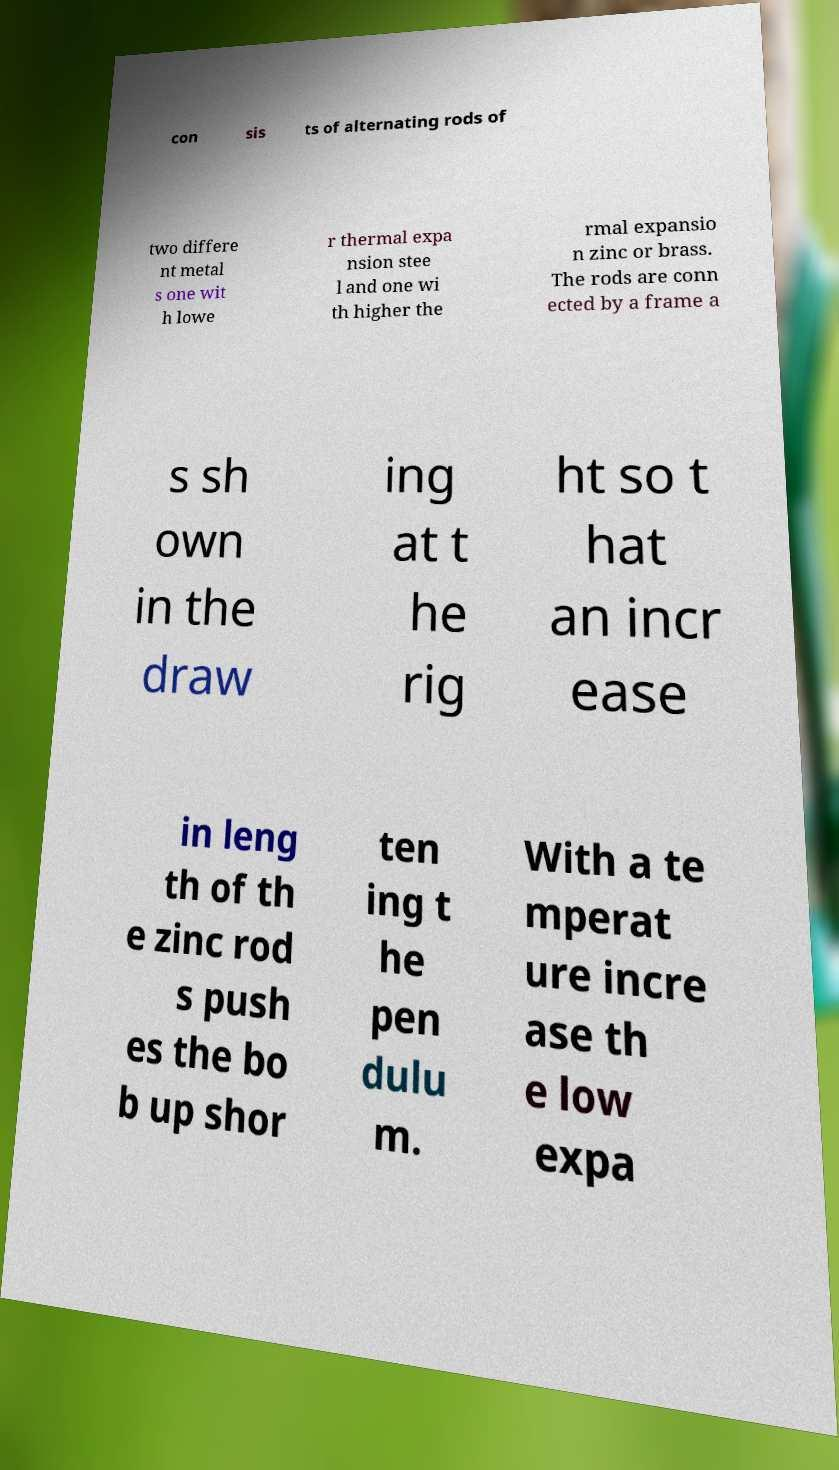For documentation purposes, I need the text within this image transcribed. Could you provide that? con sis ts of alternating rods of two differe nt metal s one wit h lowe r thermal expa nsion stee l and one wi th higher the rmal expansio n zinc or brass. The rods are conn ected by a frame a s sh own in the draw ing at t he rig ht so t hat an incr ease in leng th of th e zinc rod s push es the bo b up shor ten ing t he pen dulu m. With a te mperat ure incre ase th e low expa 